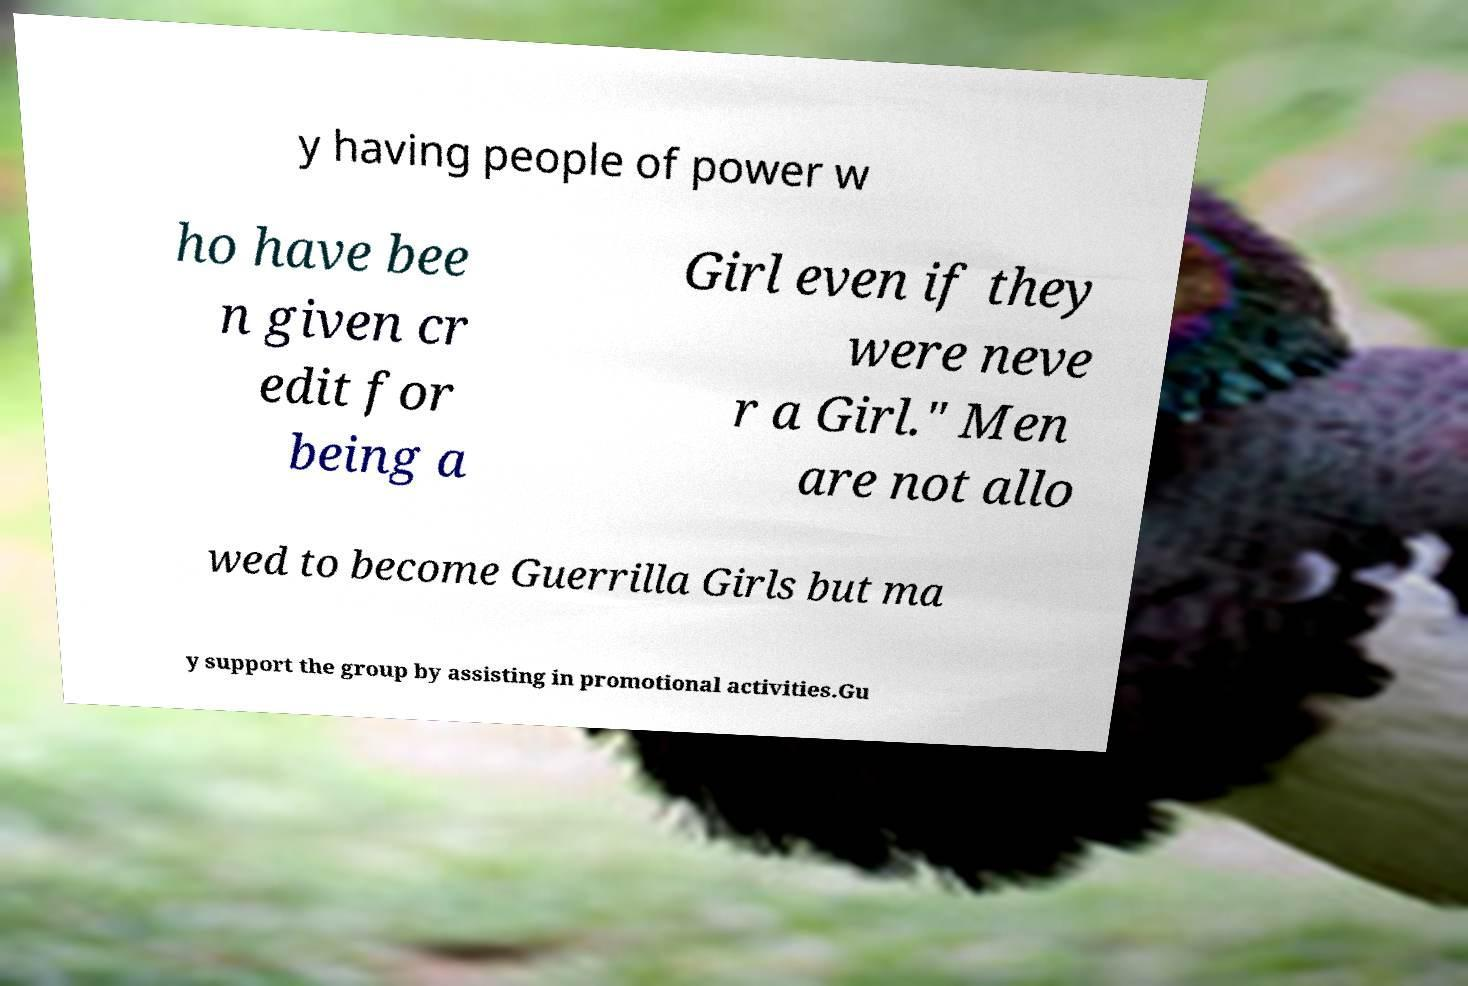Can you read and provide the text displayed in the image?This photo seems to have some interesting text. Can you extract and type it out for me? y having people of power w ho have bee n given cr edit for being a Girl even if they were neve r a Girl." Men are not allo wed to become Guerrilla Girls but ma y support the group by assisting in promotional activities.Gu 